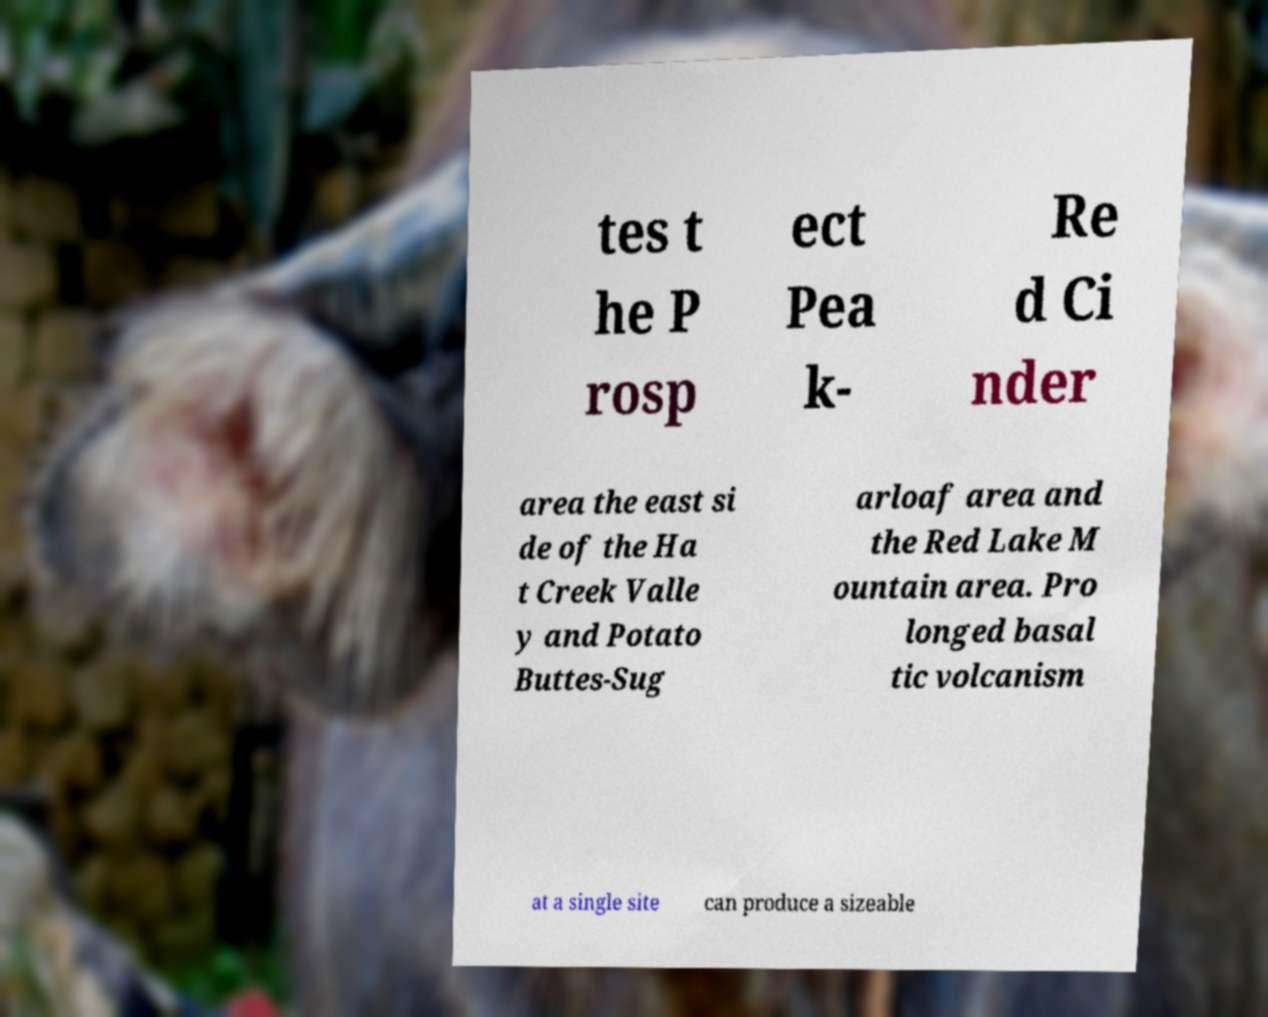Can you read and provide the text displayed in the image?This photo seems to have some interesting text. Can you extract and type it out for me? tes t he P rosp ect Pea k- Re d Ci nder area the east si de of the Ha t Creek Valle y and Potato Buttes-Sug arloaf area and the Red Lake M ountain area. Pro longed basal tic volcanism at a single site can produce a sizeable 